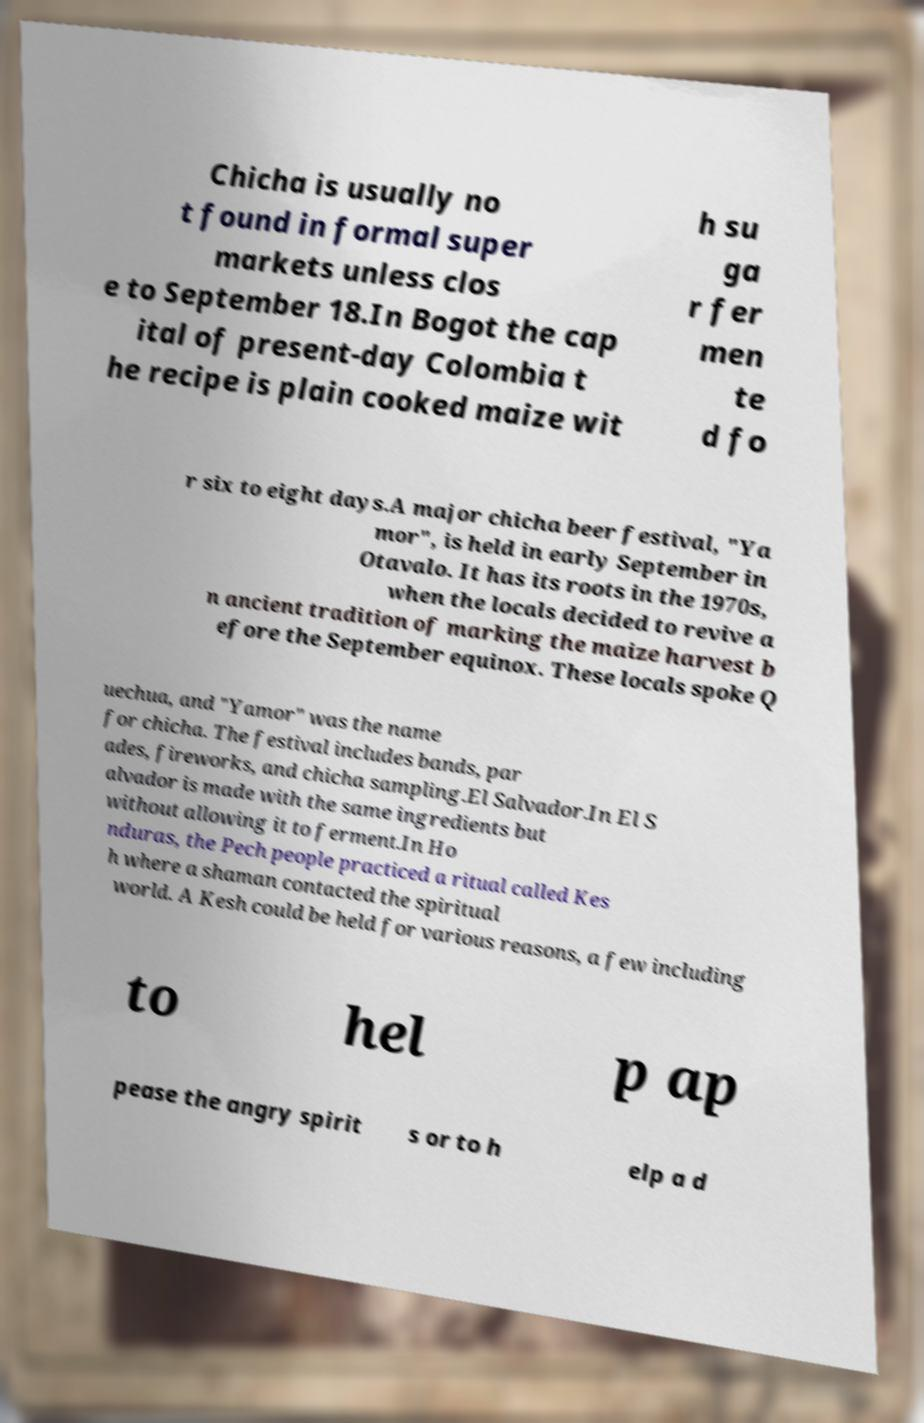Can you accurately transcribe the text from the provided image for me? Chicha is usually no t found in formal super markets unless clos e to September 18.In Bogot the cap ital of present-day Colombia t he recipe is plain cooked maize wit h su ga r fer men te d fo r six to eight days.A major chicha beer festival, "Ya mor", is held in early September in Otavalo. It has its roots in the 1970s, when the locals decided to revive a n ancient tradition of marking the maize harvest b efore the September equinox. These locals spoke Q uechua, and "Yamor" was the name for chicha. The festival includes bands, par ades, fireworks, and chicha sampling.El Salvador.In El S alvador is made with the same ingredients but without allowing it to ferment.In Ho nduras, the Pech people practiced a ritual called Kes h where a shaman contacted the spiritual world. A Kesh could be held for various reasons, a few including to hel p ap pease the angry spirit s or to h elp a d 